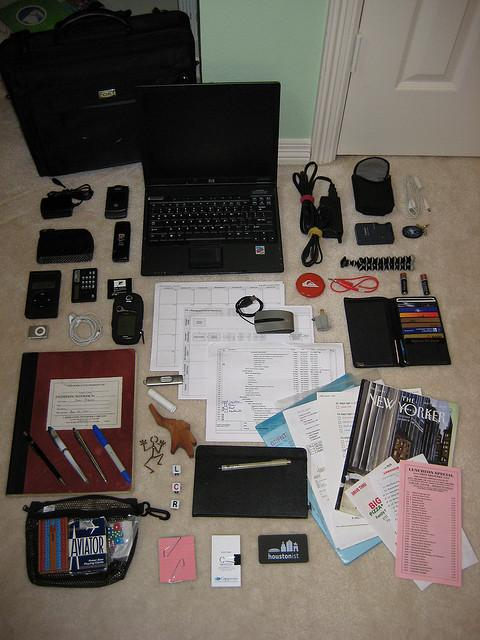How many laptops do you see? one 